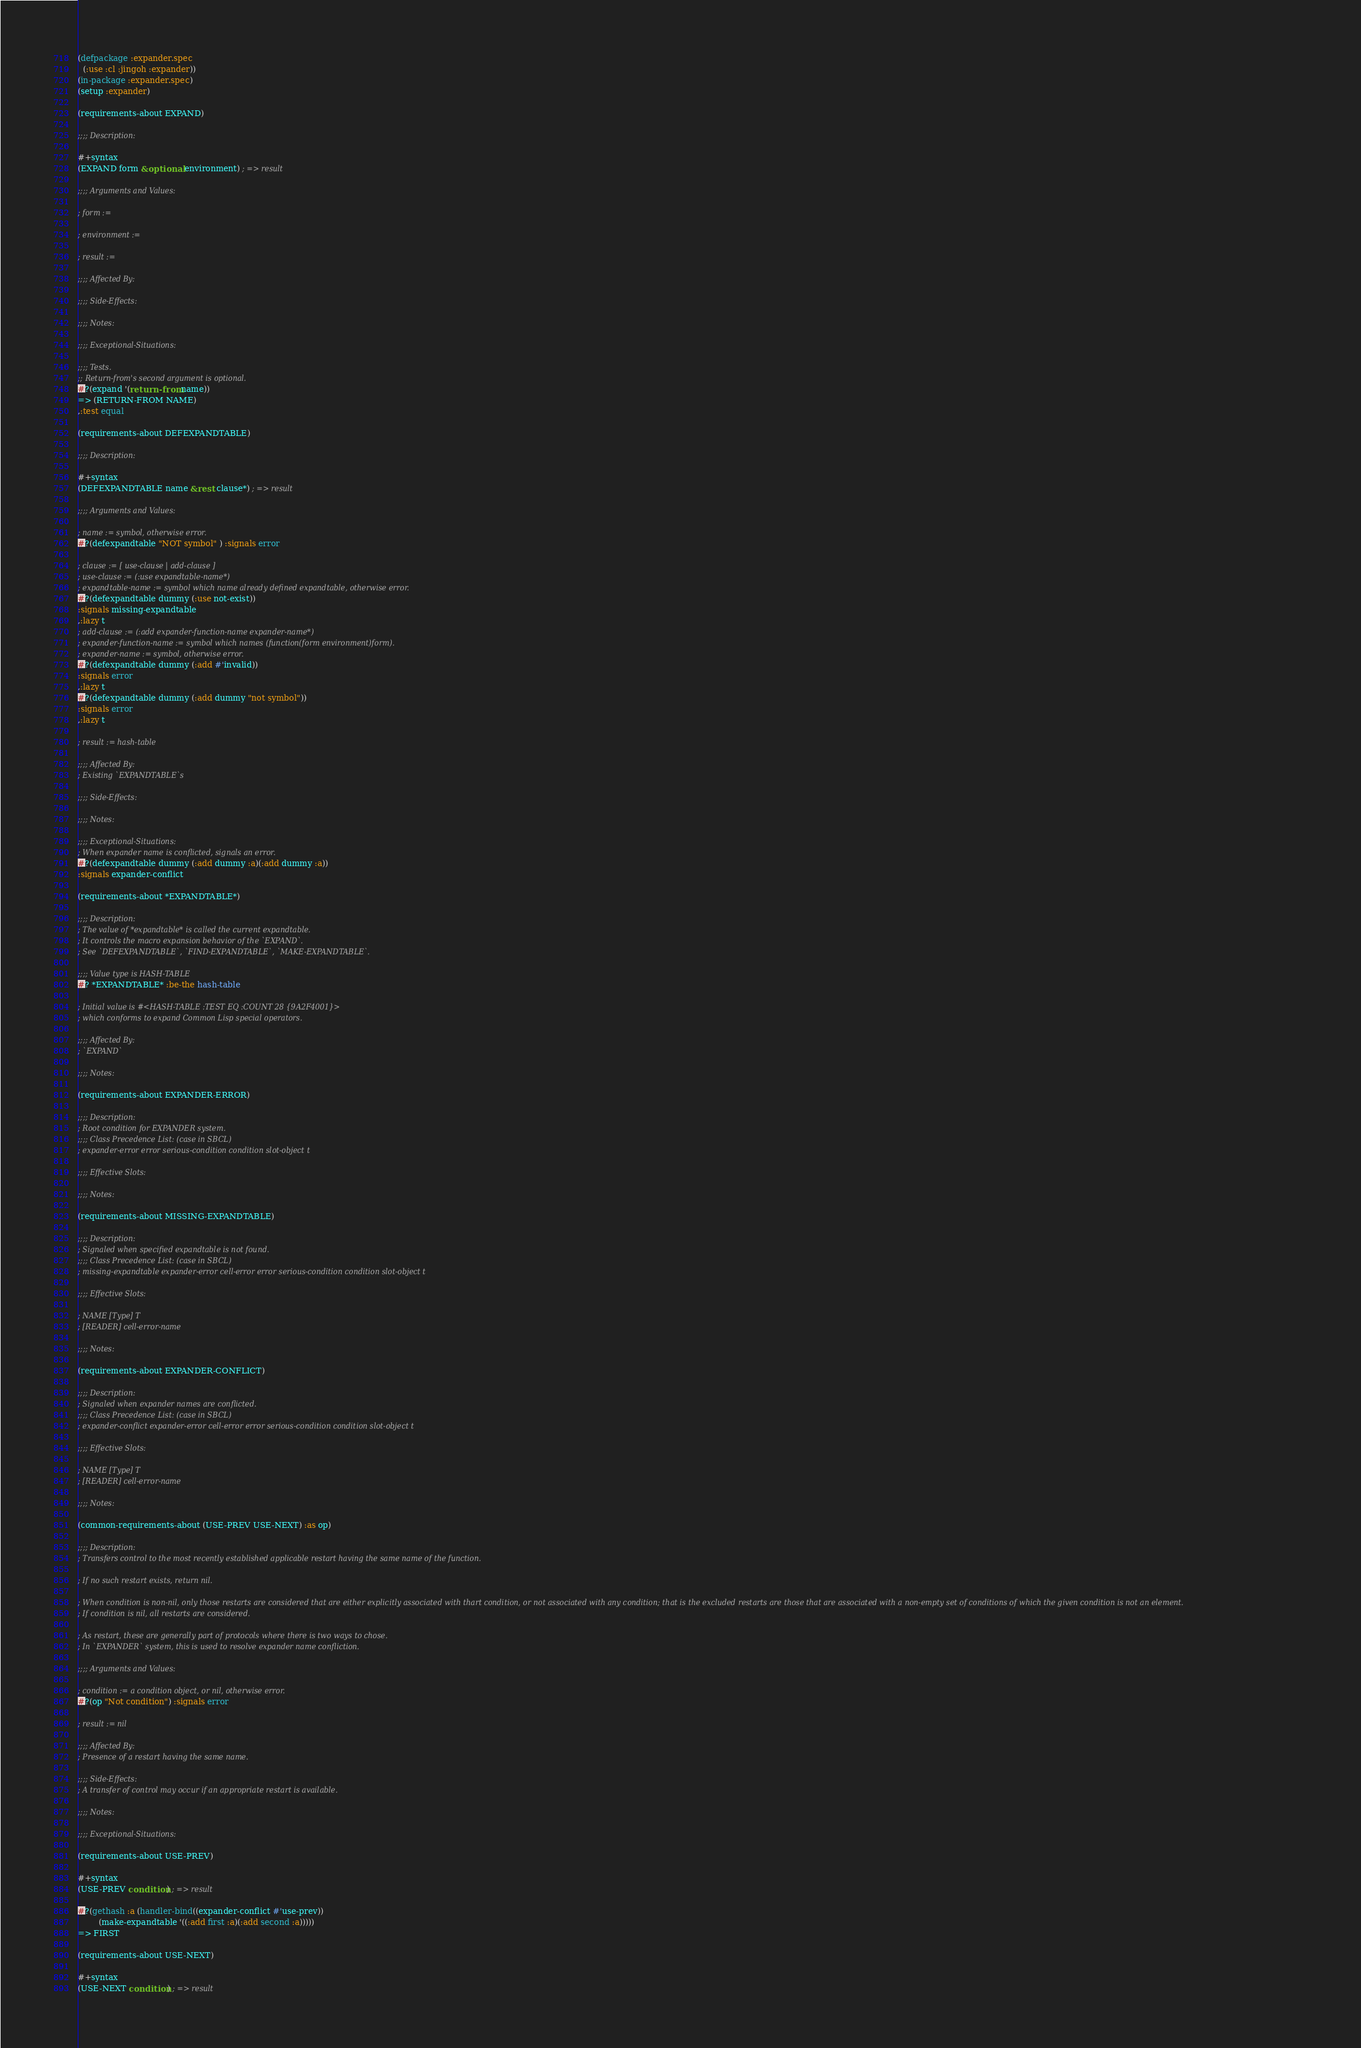<code> <loc_0><loc_0><loc_500><loc_500><_Lisp_>(defpackage :expander.spec
  (:use :cl :jingoh :expander))
(in-package :expander.spec)
(setup :expander)

(requirements-about EXPAND)

;;;; Description:

#+syntax
(EXPAND form &optional environment) ; => result

;;;; Arguments and Values:

; form := 

; environment := 

; result := 

;;;; Affected By:

;;;; Side-Effects:

;;;; Notes:

;;;; Exceptional-Situations:

;;;; Tests.
;; Return-from's second argument is optional.
#?(expand '(return-from name))
=> (RETURN-FROM NAME)
,:test equal

(requirements-about DEFEXPANDTABLE)

;;;; Description:

#+syntax
(DEFEXPANDTABLE name &rest clause*) ; => result

;;;; Arguments and Values:

; name := symbol, otherwise error.
#?(defexpandtable "NOT symbol" ) :signals error

; clause := [ use-clause | add-clause ]
; use-clause := (:use expandtable-name*)
; expandtable-name := symbol which name already defined expandtable, otherwise error.
#?(defexpandtable dummy (:use not-exist))
:signals missing-expandtable
,:lazy t
; add-clause := (:add expander-function-name expander-name*)
; expander-function-name := symbol which names (function(form environment)form).
; expander-name := symbol, otherwise error.
#?(defexpandtable dummy (:add #'invalid))
:signals error
,:lazy t
#?(defexpandtable dummy (:add dummy "not symbol"))
:signals error
,:lazy t

; result := hash-table

;;;; Affected By:
; Existing `EXPANDTABLE`s

;;;; Side-Effects:

;;;; Notes:

;;;; Exceptional-Situations:
; When expander name is conflicted, signals an error.
#?(defexpandtable dummy (:add dummy :a)(:add dummy :a))
:signals expander-conflict

(requirements-about *EXPANDTABLE*)

;;;; Description:
; The value of *expandtable* is called the current expandtable.
; It controls the macro expansion behavior of the `EXPAND`.
; See `DEFEXPANDTABLE`, `FIND-EXPANDTABLE`, `MAKE-EXPANDTABLE`.

;;;; Value type is HASH-TABLE
#? *EXPANDTABLE* :be-the hash-table

; Initial value is #<HASH-TABLE :TEST EQ :COUNT 28 {9A2F4001}>
; which conforms to expand Common Lisp special operators.

;;;; Affected By:
; `EXPAND`

;;;; Notes:

(requirements-about EXPANDER-ERROR)

;;;; Description:
; Root condition for EXPANDER system.
;;;; Class Precedence List: (case in SBCL)
; expander-error error serious-condition condition slot-object t

;;;; Effective Slots:

;;;; Notes:

(requirements-about MISSING-EXPANDTABLE)

;;;; Description:
; Signaled when specified expandtable is not found.
;;;; Class Precedence List: (case in SBCL)
; missing-expandtable expander-error cell-error error serious-condition condition slot-object t

;;;; Effective Slots:

; NAME [Type] T
; [READER] cell-error-name

;;;; Notes:

(requirements-about EXPANDER-CONFLICT)

;;;; Description:
; Signaled when expander names are conflicted.
;;;; Class Precedence List: (case in SBCL)
; expander-conflict expander-error cell-error error serious-condition condition slot-object t

;;;; Effective Slots:

; NAME [Type] T
; [READER] cell-error-name

;;;; Notes:

(common-requirements-about (USE-PREV USE-NEXT) :as op)

;;;; Description:
; Transfers control to the most recently established applicable restart having the same name of the function.

; If no such restart exists, return nil.

; When condition is non-nil, only those restarts are considered that are either explicitly associated with thart condition, or not associated with any condition; that is the excluded restarts are those that are associated with a non-empty set of conditions of which the given condition is not an element.
; If condition is nil, all restarts are considered.

; As restart, these are generally part of protocols where there is two ways to chose.
; In `EXPANDER` system, this is used to resolve expander name confliction.

;;;; Arguments and Values:

; condition := a condition object, or nil, otherwise error.
#?(op "Not condition") :signals error

; result := nil

;;;; Affected By:
; Presence of a restart having the same name.

;;;; Side-Effects:
; A transfer of control may occur if an appropriate restart is available.

;;;; Notes:

;;;; Exceptional-Situations:

(requirements-about USE-PREV)

#+syntax
(USE-PREV condition) ; => result

#?(gethash :a (handler-bind((expander-conflict #'use-prev))
		(make-expandtable '((:add first :a)(:add second :a)))))
=> FIRST

(requirements-about USE-NEXT)

#+syntax
(USE-NEXT condition) ; => result
</code> 